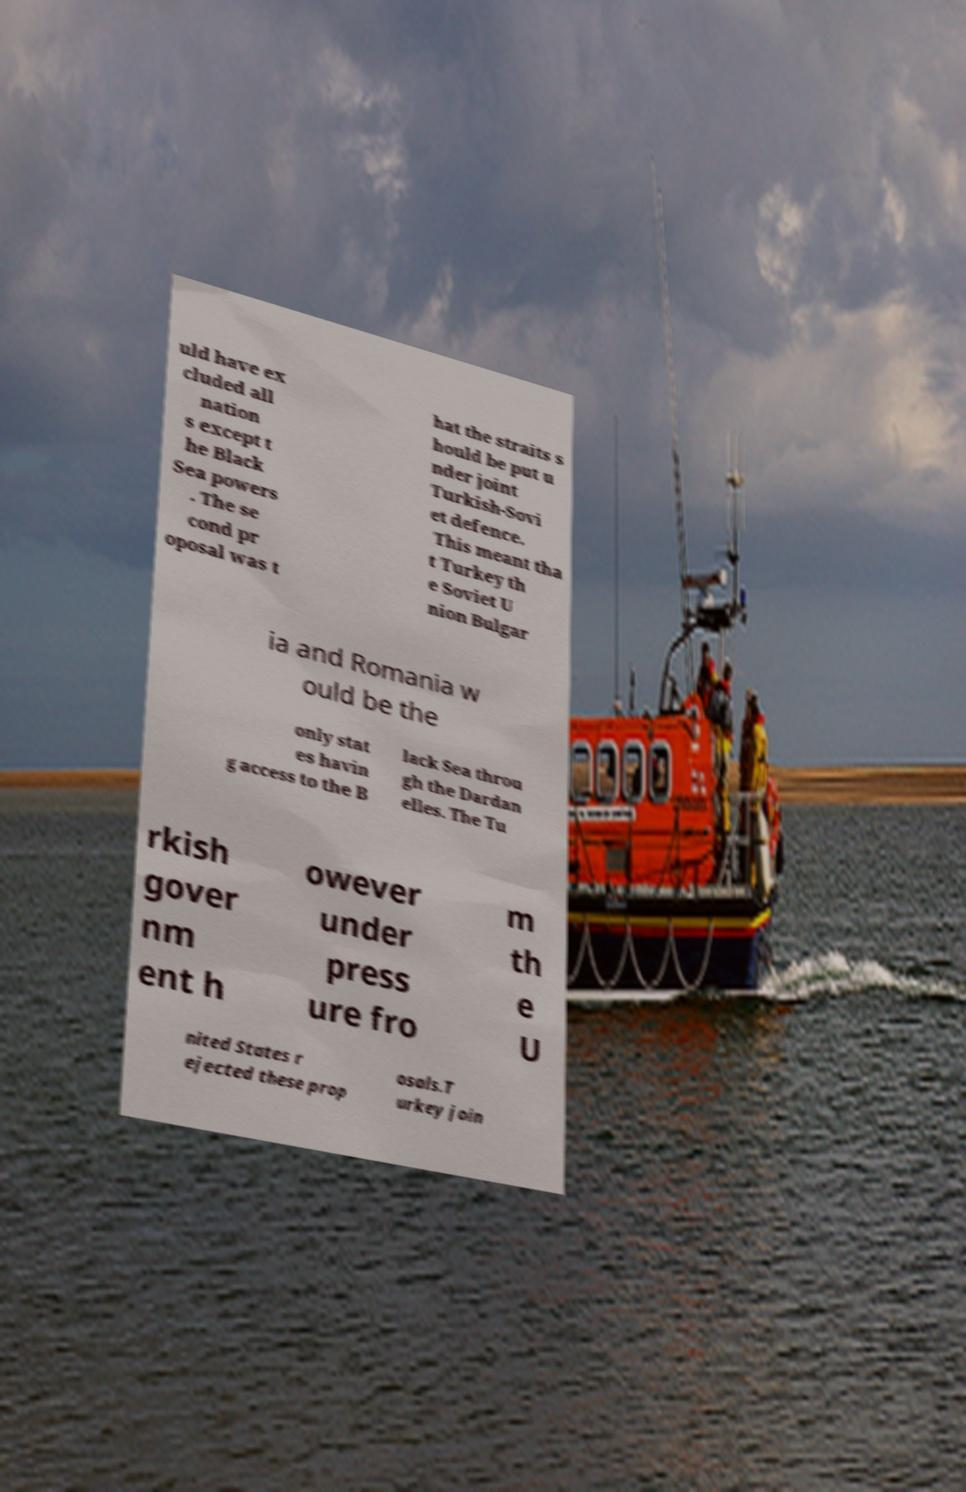Can you accurately transcribe the text from the provided image for me? uld have ex cluded all nation s except t he Black Sea powers . The se cond pr oposal was t hat the straits s hould be put u nder joint Turkish-Sovi et defence. This meant tha t Turkey th e Soviet U nion Bulgar ia and Romania w ould be the only stat es havin g access to the B lack Sea throu gh the Dardan elles. The Tu rkish gover nm ent h owever under press ure fro m th e U nited States r ejected these prop osals.T urkey join 